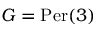Convert formula to latex. <formula><loc_0><loc_0><loc_500><loc_500>G = { P e r } ( 3 )</formula> 